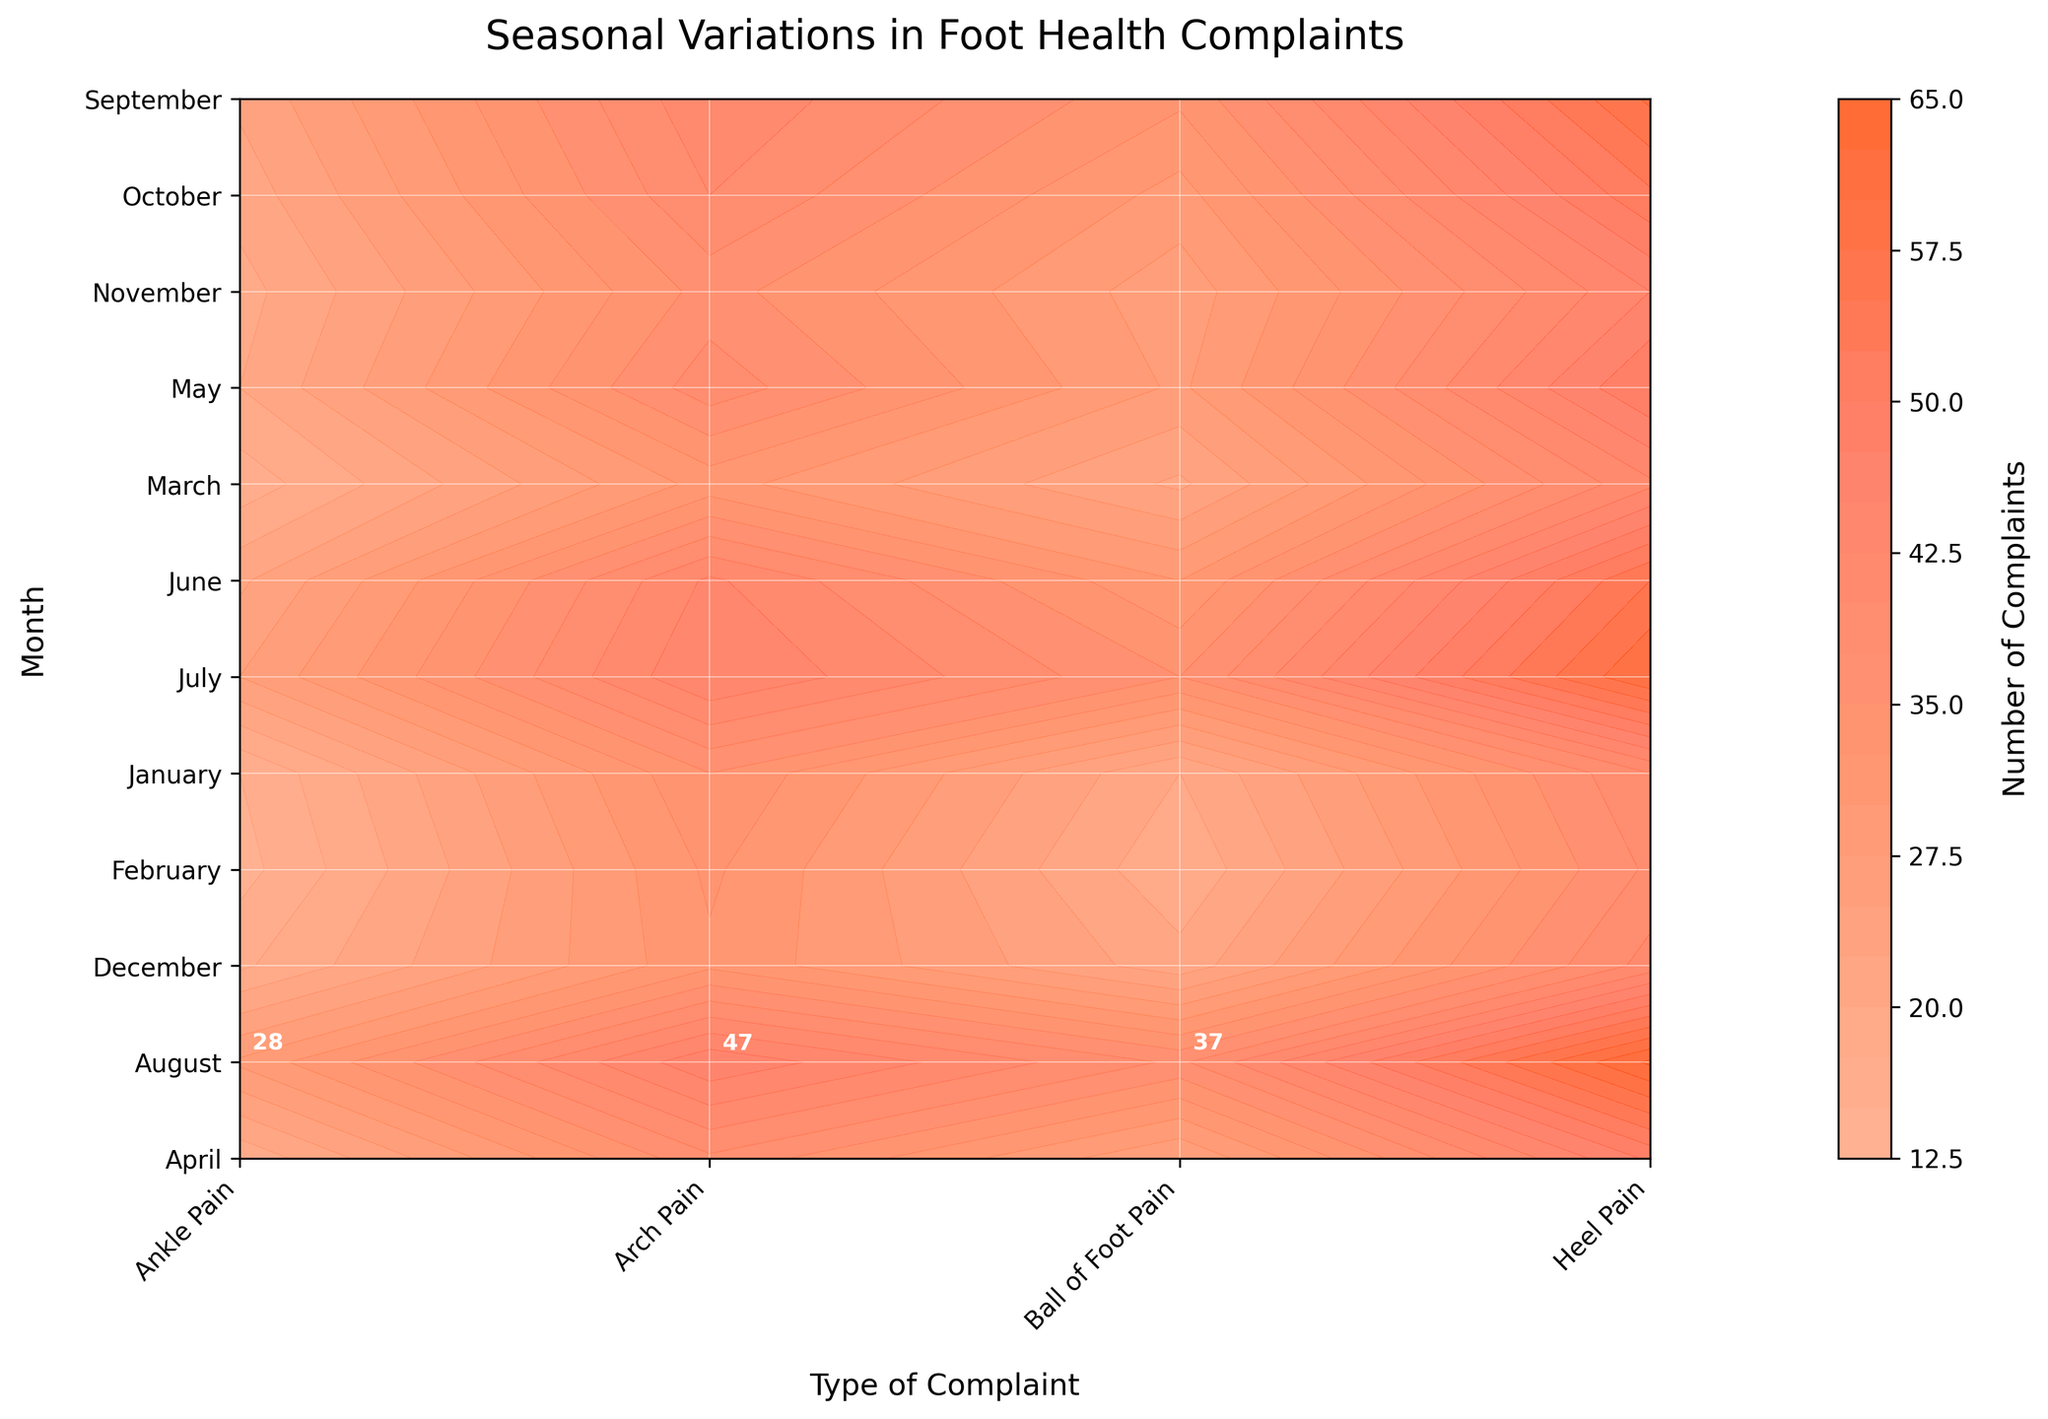what is the title of the figure? The title is displayed at the top of the figure, which reads "Seasonal Variations in Foot Health Complaints".
Answer: Seasonal Variations in Foot Health Complaints Which month has the lowest number of heel pain complaints? By observing the contour plot and locating the position of heel pain complaints, you can see that January has the lowest number at around 40 complaints.
Answer: January Which type of foot complaint has the highest peak in July? The highest peak in July can be identified from the contour plot. The annotated value for heel pain is the highest in July with 60 complaints.
Answer: Heel Pain What is the color used for the highest number of complaints? The contour plot uses a colormap to represent the number of complaints. The highest values are represented in the darkest shade of the orange-red color.
Answer: Dark orange-red What is the difference in heel pain complaints between May and September? From the contour plot, the number of heel pain complaints in May is 50 and in September it is 58. The difference is 58 - 50 = 8.
Answer: 8 What is the average number of arch pain complaints from January to March? From the contour plot, the number of arch pain complaints in January is 35, February is 33, and March is 31. The average is (35 + 33 + 31) / 3 = 33.
Answer: 33 During which month does ankle pain peak, and what is the value? Looking at the contour plot, the highest number of ankle pain complaints is in August with a maximum value of 28.
Answer: August, 28 Compare the number of ball of foot pain complaints between February and October. Which month has more, and by how much? Observing the contour plot, February has 18 complaints and October has 29 complaints. October has 29 - 18 = 11 more complaints than February.
Answer: October, 11 Is there a month where the complaints for all types of foot pain are at their maximum for the year? If so, which one? By checking each type of complaint and their maximum values annotated on the contour plot, it can be seen that no single month has the maximum for all types of complaints.
Answer: No 